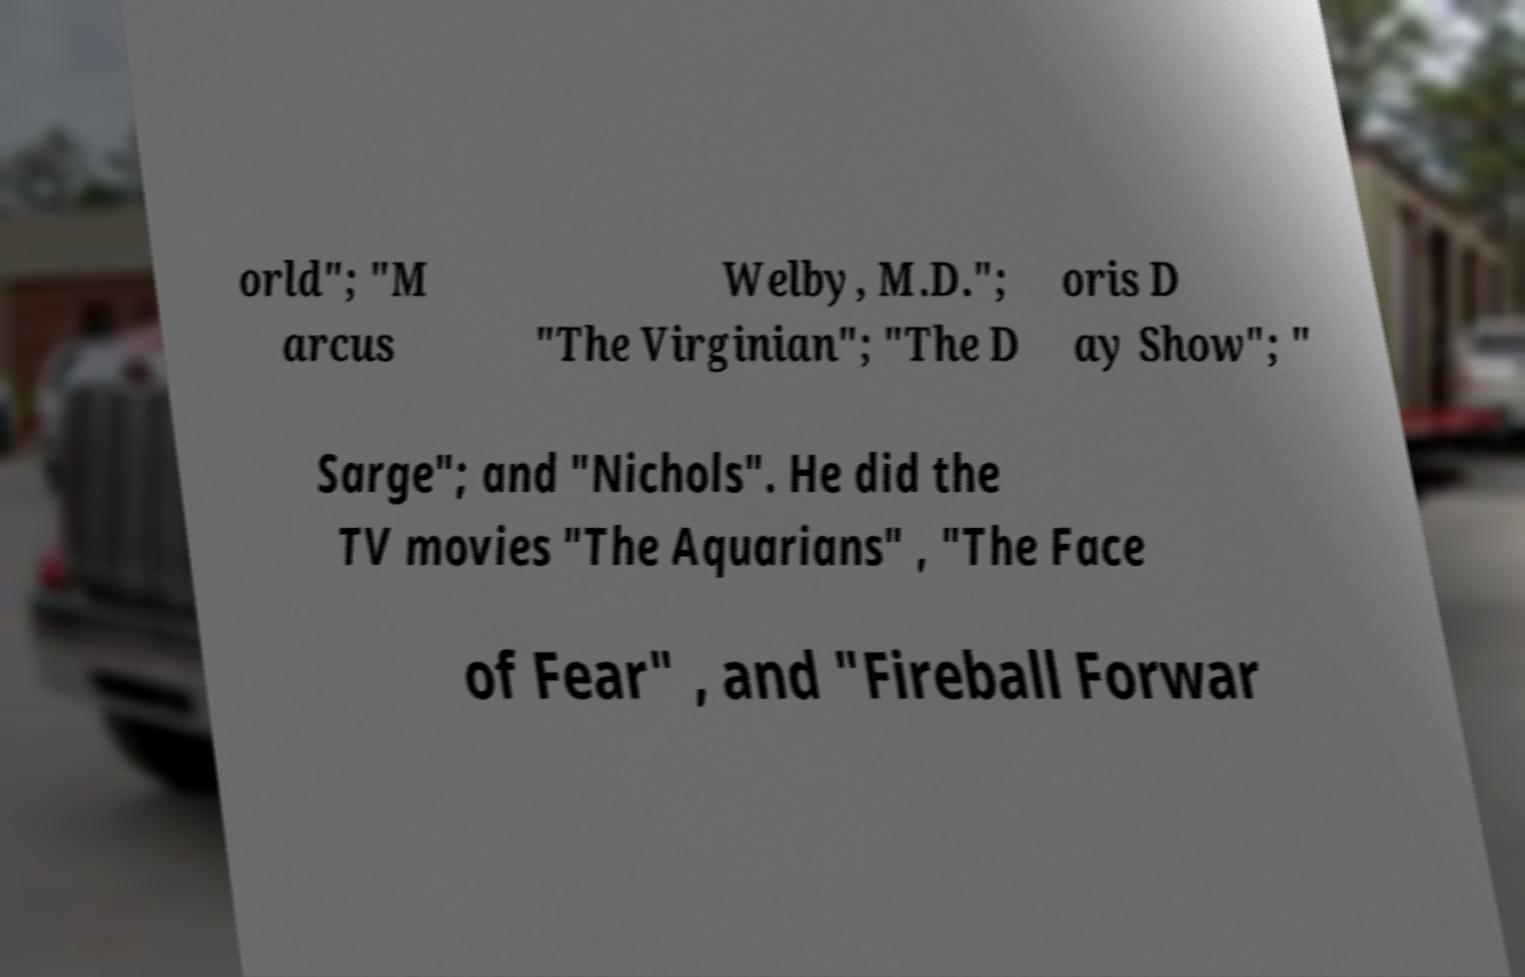Please identify and transcribe the text found in this image. orld"; "M arcus Welby, M.D."; "The Virginian"; "The D oris D ay Show"; " Sarge"; and "Nichols". He did the TV movies "The Aquarians" , "The Face of Fear" , and "Fireball Forwar 